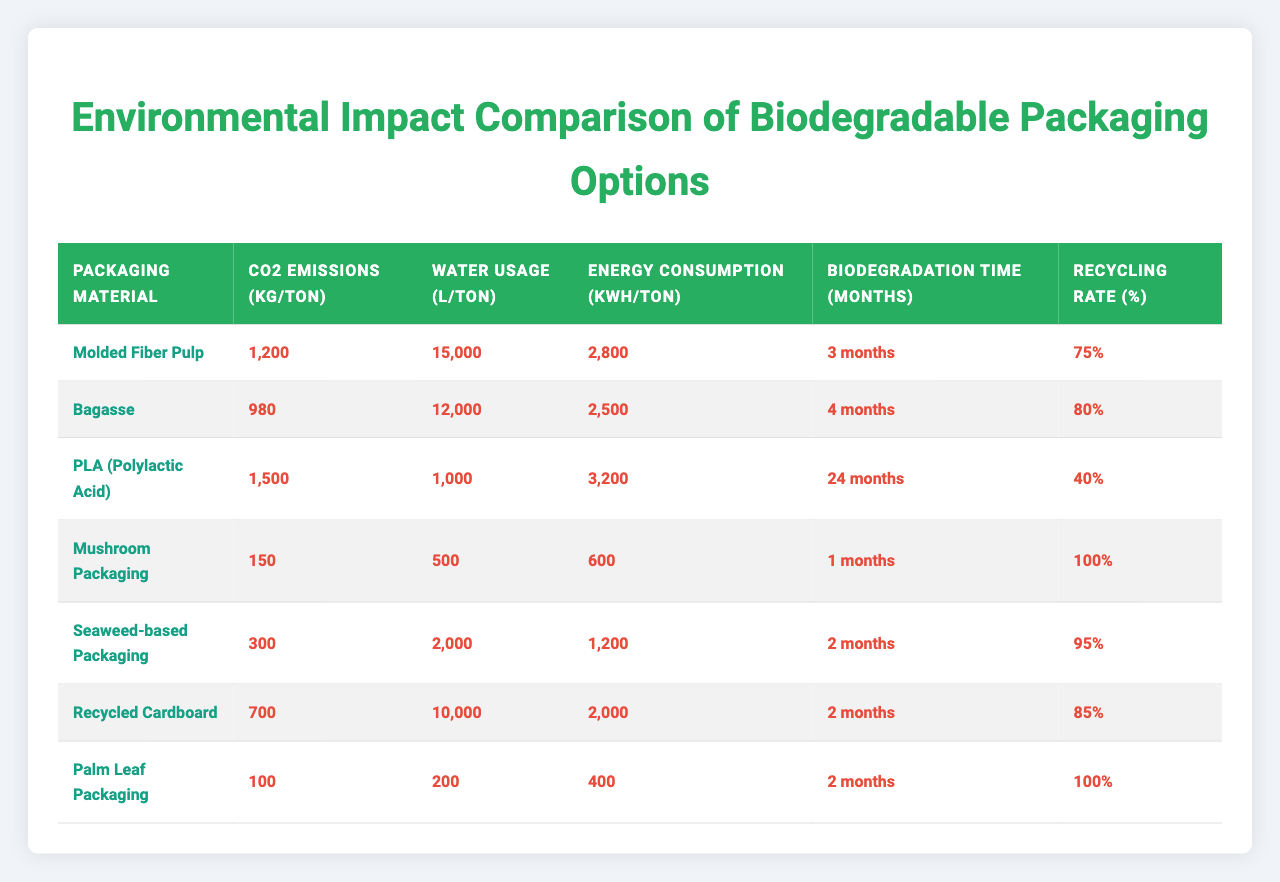What are the CO2 emissions for Molded Fiber Pulp? The table shows that the CO2 emissions for Molded Fiber Pulp are 1200 kg/ton.
Answer: 1200 kg/ton Which packaging material has the longest biodegradation time? The biodegradation times for each material are compared, and PLA (Polylactic Acid) has the longest time at 24 months.
Answer: PLA (Polylactic Acid) What is the recycling rate of Mushroom Packaging? The recycling rate for Mushroom Packaging is displayed in the table as 100%.
Answer: 100% What is the average water usage among the packaging materials listed? The water usages are 15000, 12000, 1000, 500, 2000, 10000, and 200 L/ton. Summing them gives 30,712 L. Divided by 7 materials results in 30,712/7 = 4387.43 L/ton.
Answer: 4387.43 L/ton Is the CO2 emissions of Palm Leaf Packaging lower than that of Bagasse? Palm Leaf Packaging has CO2 emissions of 100 kg/ton, while Bagasse has 980 kg/ton. Since 100 < 980, this statement is true.
Answer: Yes Which packaging material has the lowest energy consumption? By comparing the energy consumption values of each material, Mushroom Packaging has the lowest consumption at 600 kWh/ton.
Answer: Mushroom Packaging What is the total CO2 emissions for all materials combined? Adding up all CO2 emissions gives: 1200 + 980 + 1500 + 150 + 300 + 700 + 100 = 3980 kg/ton.
Answer: 3980 kg/ton Does any packaging material require less than 1000 liters of water? The table shows that Mushroom Packaging requires only 500 L/ton, which is less than 1000 L, confirming the statement is true.
Answer: Yes What is the average biodegradation time of the materials? The biodegradation times are 3, 4, 24, 1, 2, 2, and 2 months. The total is 38 months. Dividing by 7 gives an average of 38/7 = 5.43 months.
Answer: 5.43 months How much more energy does PLA consume compared to Seaweed-based Packaging? The energy consumption for PLA is 3200 kWh/ton and for Seaweed-based Packaging is 1200 kWh/ton. The difference is 3200 - 1200 = 2000 kWh/ton.
Answer: 2000 kWh/ton 